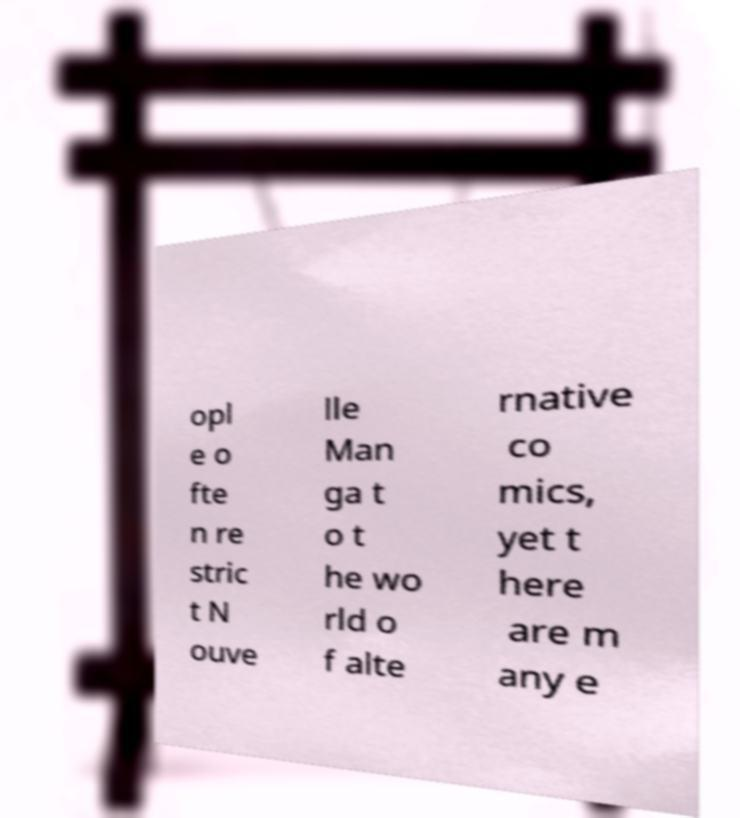For documentation purposes, I need the text within this image transcribed. Could you provide that? opl e o fte n re stric t N ouve lle Man ga t o t he wo rld o f alte rnative co mics, yet t here are m any e 